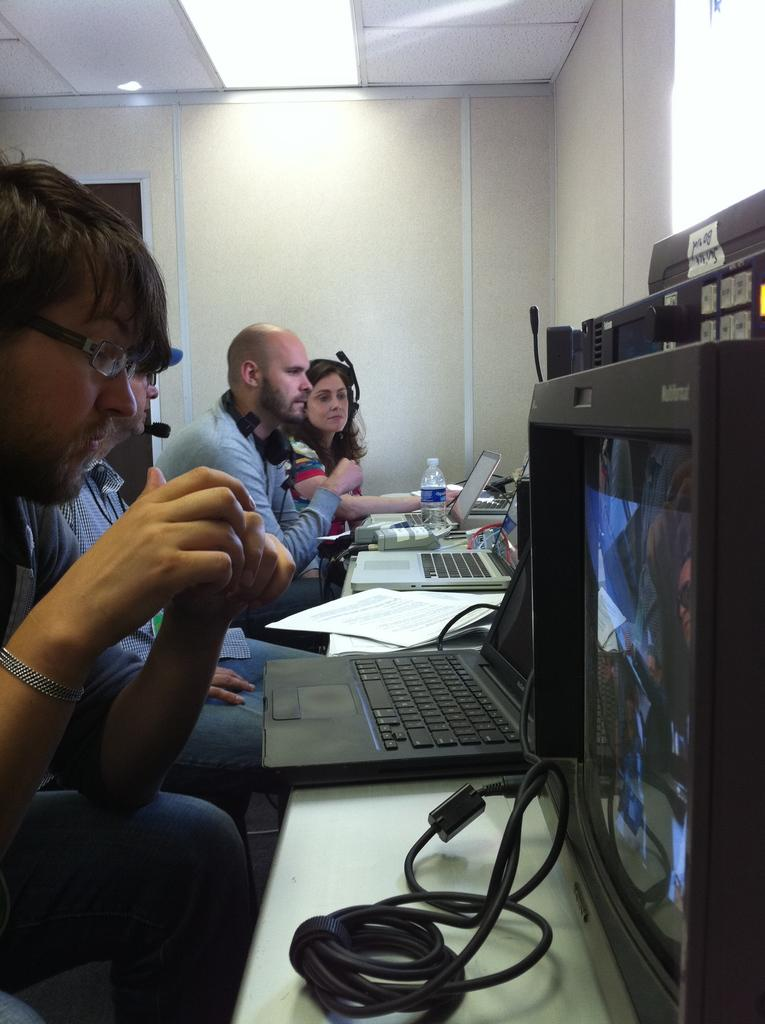Who is present in the image? There are men in the picture. What are the men doing in the image? The men are sitting in front of a table. What objects can be seen on the table? There are laptops on the table. What type of lighting is present in the image? There are lights on the ceiling. What type of waves can be seen crashing on the shore in the image? There are no waves or shore present in the image; it features men sitting at a table with laptops. What material is the leather couch made of in the image? There is no leather couch present in the image. 